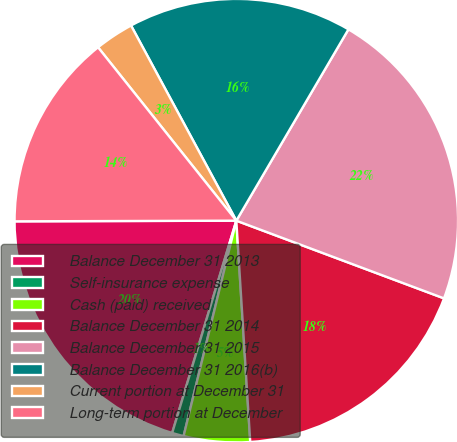Convert chart. <chart><loc_0><loc_0><loc_500><loc_500><pie_chart><fcel>Balance December 31 2013<fcel>Self-insurance expense<fcel>Cash (paid) received<fcel>Balance December 31 2014<fcel>Balance December 31 2015<fcel>Balance December 31 2016(b)<fcel>Current portion at December 31<fcel>Long-term portion at December<nl><fcel>20.28%<fcel>0.85%<fcel>4.82%<fcel>18.3%<fcel>22.26%<fcel>16.31%<fcel>2.84%<fcel>14.33%<nl></chart> 